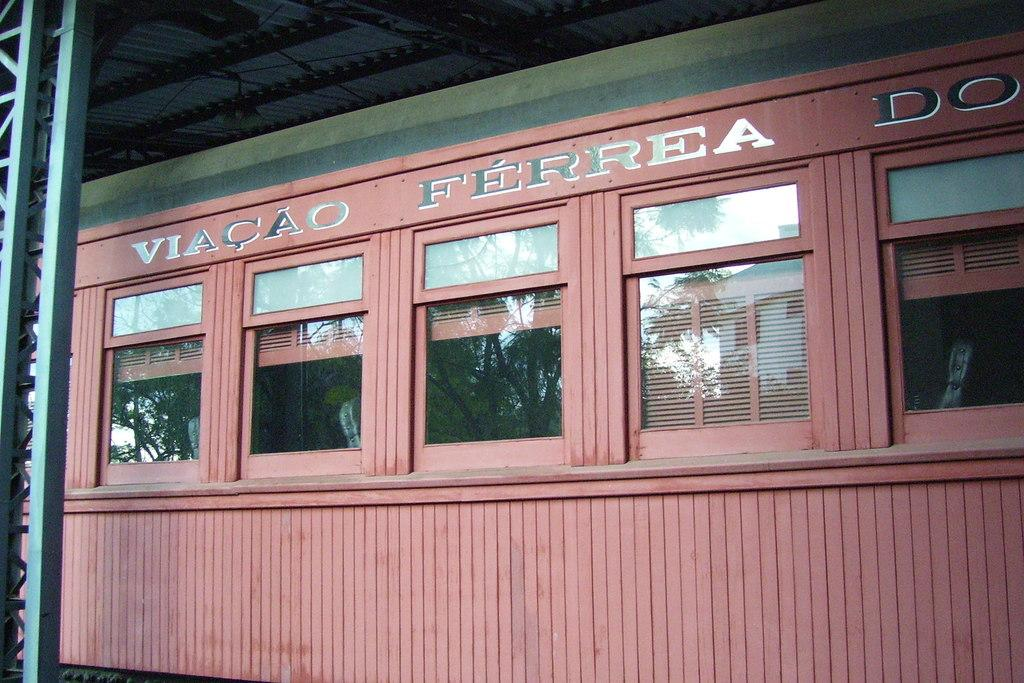What type of structure is present in the image? There is a shed in the image. What color is the shed? The shed is brown in color. Are there any openings in the shed? Yes, there are glass windows on the shed. What type of yarn is used to decorate the shed in the image? There is no yarn present in the image; the shed is simply brown with glass windows. 